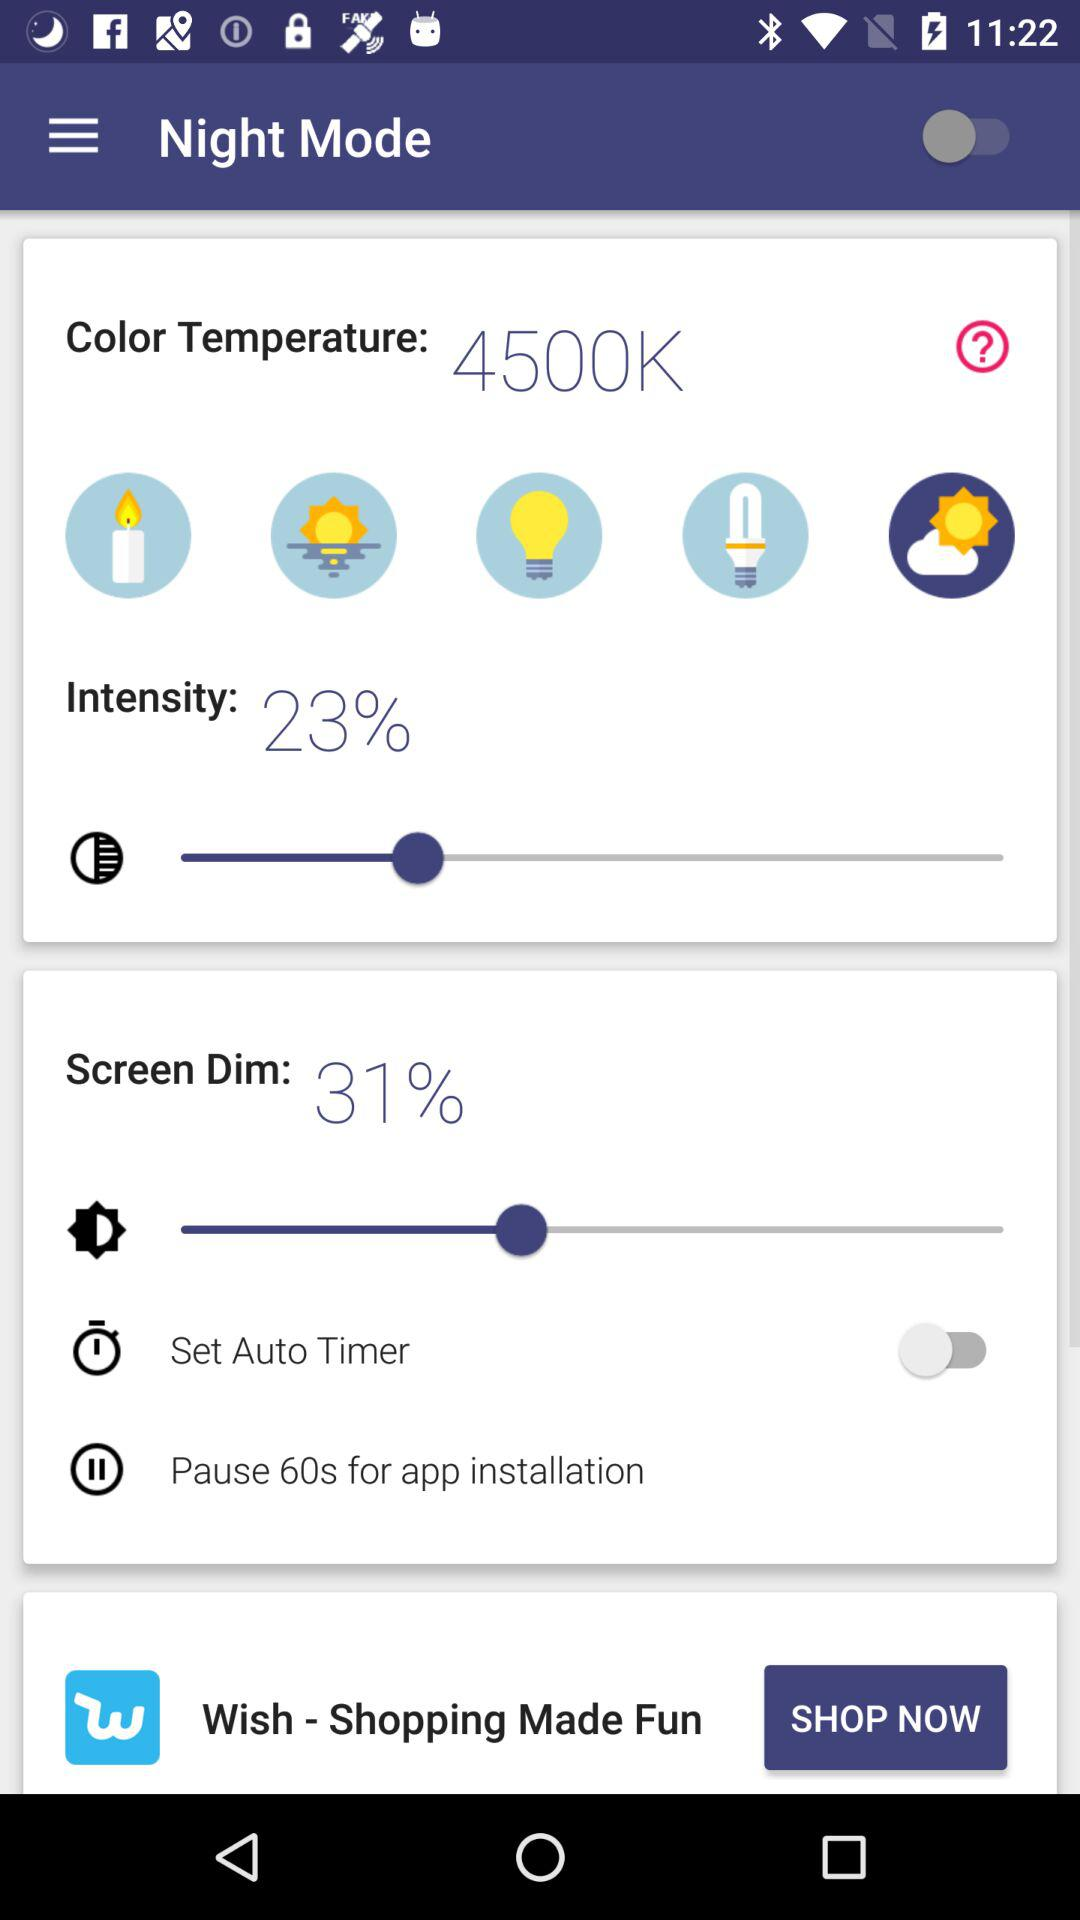What is the color temperature? The color temperature is 4500K. 